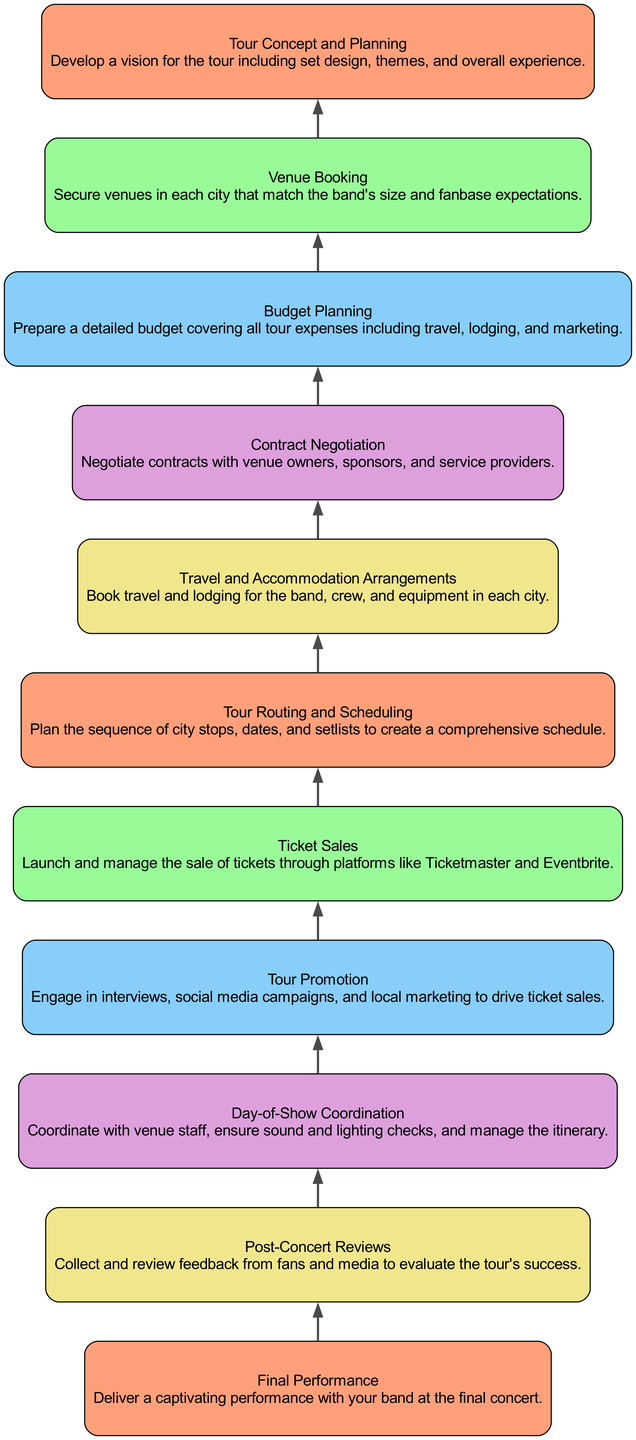What's the first step in the tour organization process? The first step in the tour organization process is "Tour Concept and Planning," as indicated at the bottom of the diagram. This step outlines the initial vision for the tour.
Answer: Tour Concept and Planning How many total steps are outlined in the tour organizing process? The diagram consists of 11 defined steps, which are each represented by a node in the flowchart. By counting each node from "Final Performance" to "Tour Concept and Planning," we arrive at the total.
Answer: 11 What is the final step before the performance? The final step before the performance is "Day-of-Show Coordination," which is the step directly preceding "Final Performance" in the upward flow of the diagram.
Answer: Day-of-Show Coordination Which step comes after "Ticket Sales"? According to the diagram, the step that follows "Ticket Sales" is "Tour Promotion," indicating that promoting the tour comes after the process of selling tickets.
Answer: Tour Promotion What is the purpose of the "Post-Concert Reviews" step? The "Post-Concert Reviews" step involves collecting and reviewing feedback from fans and media, which serves the purpose of evaluating the overall success of the tour.
Answer: Collect and review feedback What is the relationship between "Contract Negotiation" and "Budget Planning"? "Contract Negotiation" and "Budget Planning" are sequential steps, where "Contract Negotiation" occurs before "Budget Planning." Effective budget planning may rely on the outcomes of contracts negotiated with various parties.
Answer: Sequential steps How many promotional activities are indicated in the diagram? The diagram mentions one promotional activity, which is "Tour Promotion," following "Ticket Sales." This step emphasizes marketing efforts to drive ticket sales.
Answer: One What role does "Travel and Accommodation Arrangements" play in the overall tour organization? This step is crucial as it involves the logistics of booking travel and lodging for the band, crew, and equipment, which is essential for executing the tour smoothly.
Answer: Logistics of travel and lodging What step directly leads to the final performance? The step that directly leads to the final performance is "Day-of-Show Coordination," which involves all necessary preparations prior to the performance itself.
Answer: Day-of-Show Coordination 